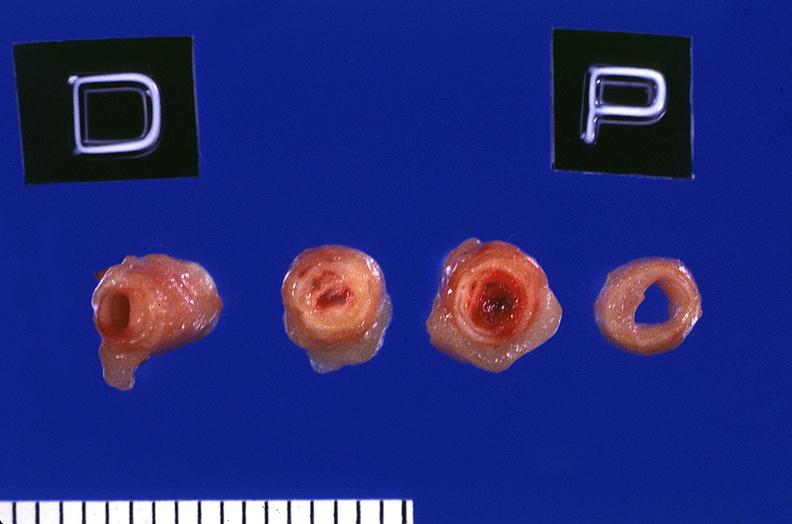what does this image show?
Answer the question using a single word or phrase. Coronary artery with atherosclerosis and thrombotic occlusion 